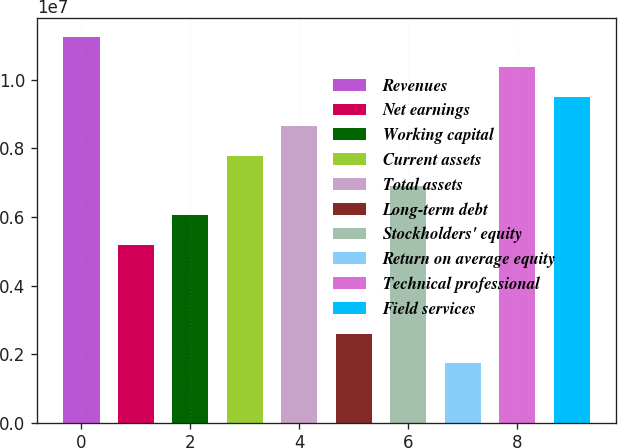Convert chart to OTSL. <chart><loc_0><loc_0><loc_500><loc_500><bar_chart><fcel>Revenues<fcel>Net earnings<fcel>Working capital<fcel>Current assets<fcel>Total assets<fcel>Long-term debt<fcel>Stockholders' equity<fcel>Return on average equity<fcel>Technical professional<fcel>Field services<nl><fcel>1.12359e+07<fcel>5.1858e+06<fcel>6.0501e+06<fcel>7.7787e+06<fcel>8.643e+06<fcel>2.5929e+06<fcel>6.9144e+06<fcel>1.7286e+06<fcel>1.03716e+07<fcel>9.5073e+06<nl></chart> 